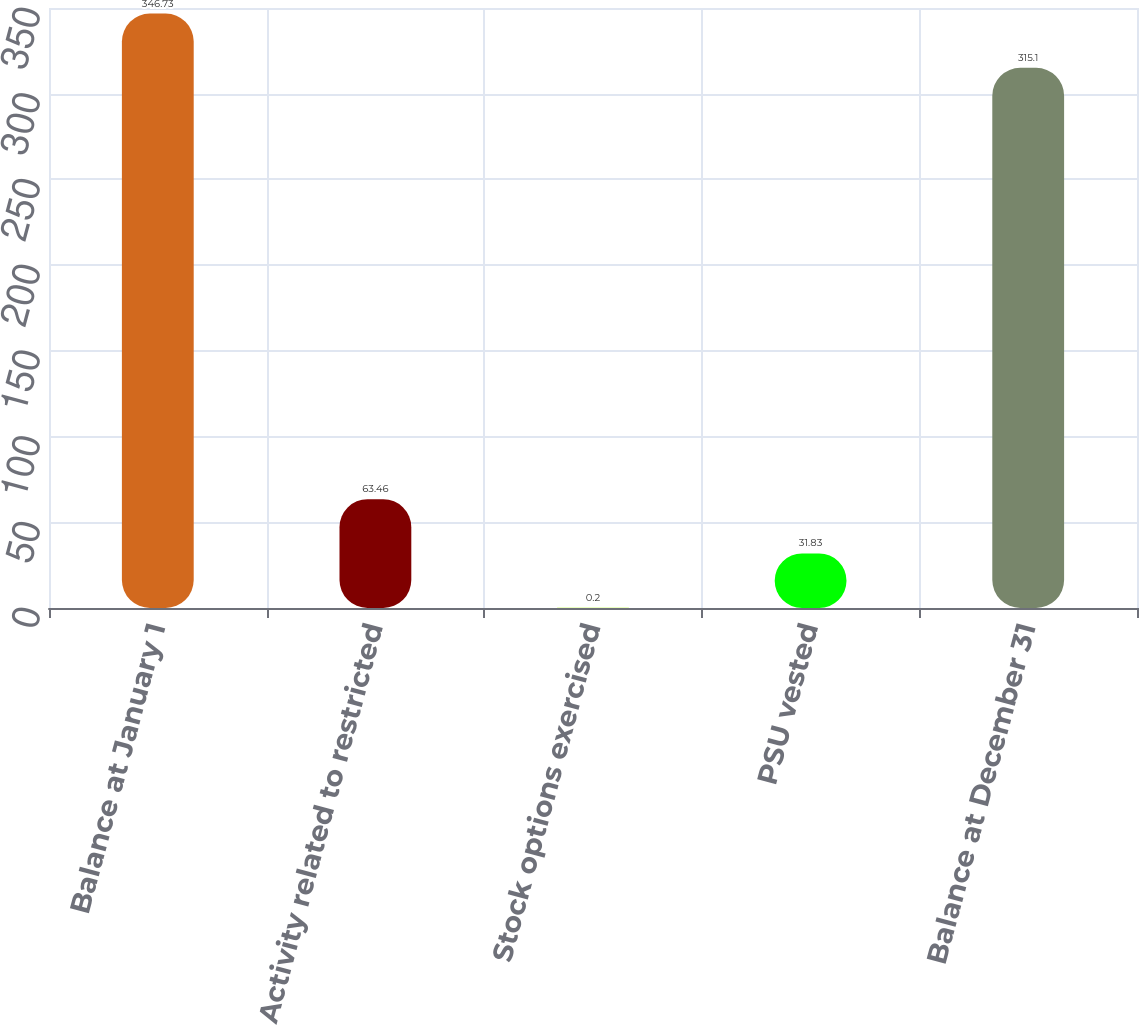<chart> <loc_0><loc_0><loc_500><loc_500><bar_chart><fcel>Balance at January 1<fcel>Activity related to restricted<fcel>Stock options exercised<fcel>PSU vested<fcel>Balance at December 31<nl><fcel>346.73<fcel>63.46<fcel>0.2<fcel>31.83<fcel>315.1<nl></chart> 